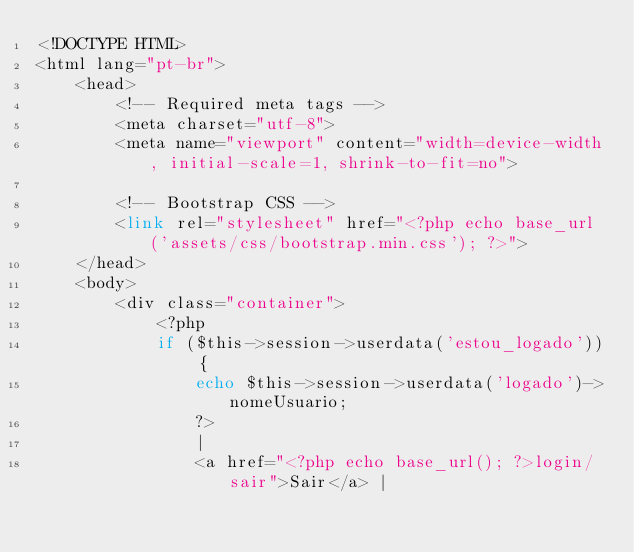<code> <loc_0><loc_0><loc_500><loc_500><_PHP_><!DOCTYPE HTML>
<html lang="pt-br">
    <head>
        <!-- Required meta tags -->
        <meta charset="utf-8">
        <meta name="viewport" content="width=device-width, initial-scale=1, shrink-to-fit=no">

        <!-- Bootstrap CSS -->
        <link rel="stylesheet" href="<?php echo base_url('assets/css/bootstrap.min.css'); ?>">
    </head>
    <body>
        <div class="container">
            <?php
            if ($this->session->userdata('estou_logado')) {
                echo $this->session->userdata('logado')->nomeUsuario;
                ?>
                | 
                <a href="<?php echo base_url(); ?>login/sair">Sair</a> | </code> 